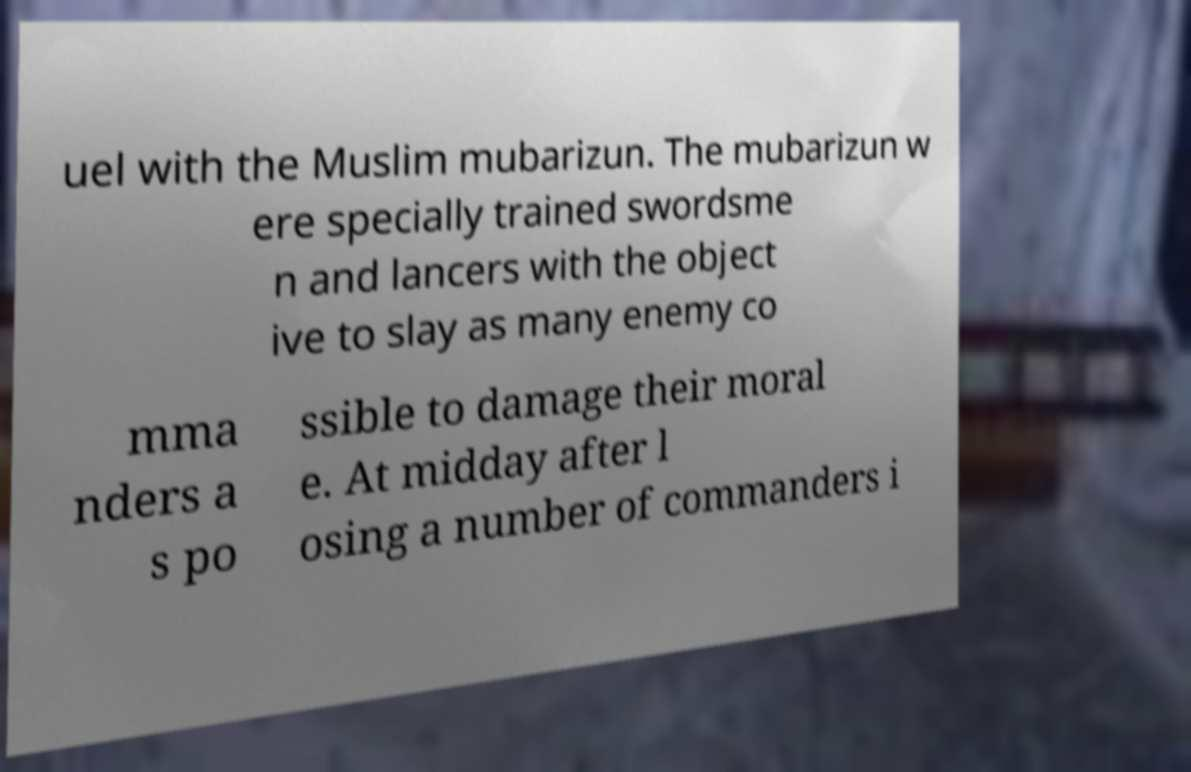I need the written content from this picture converted into text. Can you do that? uel with the Muslim mubarizun. The mubarizun w ere specially trained swordsme n and lancers with the object ive to slay as many enemy co mma nders a s po ssible to damage their moral e. At midday after l osing a number of commanders i 